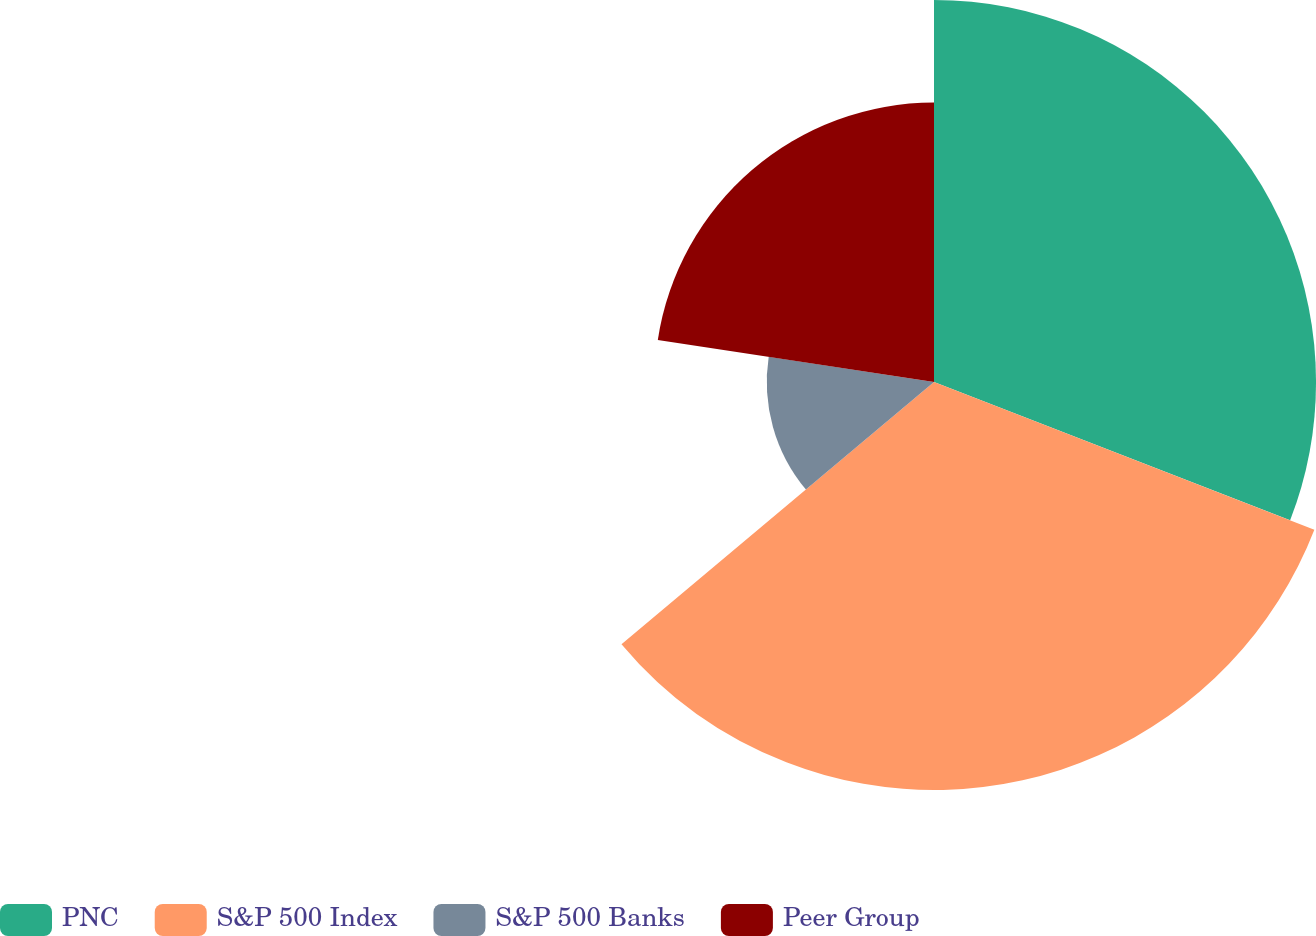<chart> <loc_0><loc_0><loc_500><loc_500><pie_chart><fcel>PNC<fcel>S&P 500 Index<fcel>S&P 500 Banks<fcel>Peer Group<nl><fcel>30.89%<fcel>32.99%<fcel>13.52%<fcel>22.59%<nl></chart> 